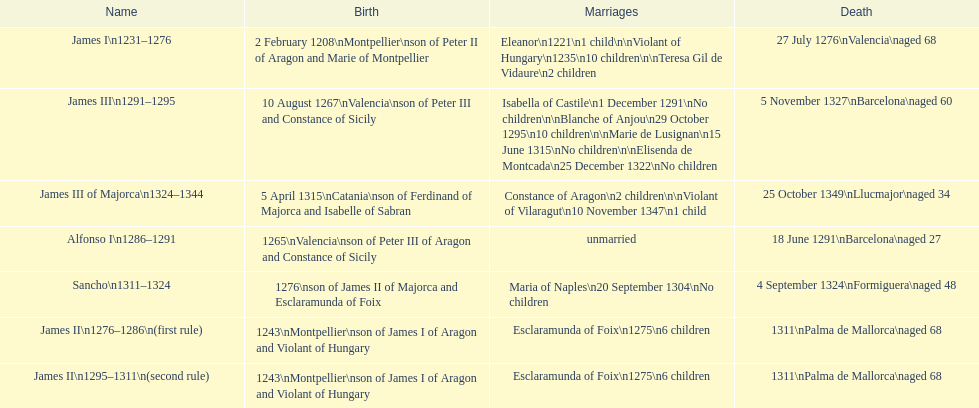How long was james ii in power, including his second rule? 26 years. 